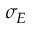Convert formula to latex. <formula><loc_0><loc_0><loc_500><loc_500>\sigma _ { E }</formula> 